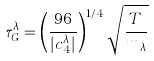Convert formula to latex. <formula><loc_0><loc_0><loc_500><loc_500>\tau _ { G } ^ { \lambda } = \left ( \frac { 9 6 } { | c ^ { \lambda } _ { 4 } | } \right ) ^ { 1 / 4 } \sqrt { \frac { T } { m _ { \lambda } } }</formula> 